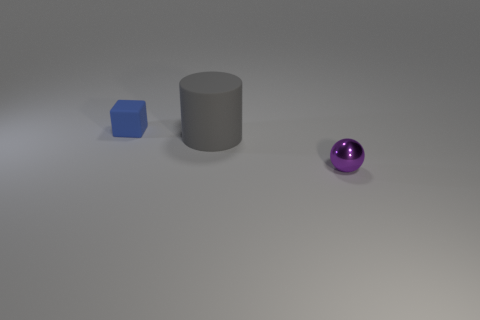Add 1 large gray cylinders. How many objects exist? 4 Subtract all blocks. How many objects are left? 2 Add 3 large cyan rubber cubes. How many large cyan rubber cubes exist? 3 Subtract 0 red cubes. How many objects are left? 3 Subtract all yellow matte cylinders. Subtract all metal objects. How many objects are left? 2 Add 1 gray rubber things. How many gray rubber things are left? 2 